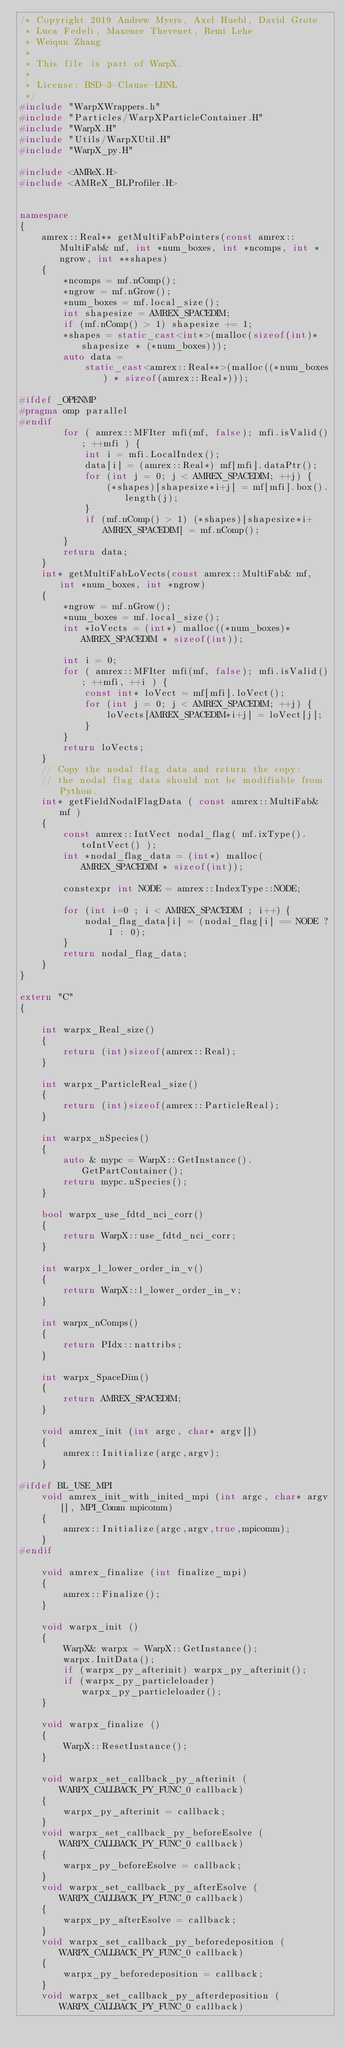Convert code to text. <code><loc_0><loc_0><loc_500><loc_500><_C++_>/* Copyright 2019 Andrew Myers, Axel Huebl, David Grote
 * Luca Fedeli, Maxence Thevenet, Remi Lehe
 * Weiqun Zhang
 *
 * This file is part of WarpX.
 *
 * License: BSD-3-Clause-LBNL
 */
#include "WarpXWrappers.h"
#include "Particles/WarpXParticleContainer.H"
#include "WarpX.H"
#include "Utils/WarpXUtil.H"
#include "WarpX_py.H"

#include <AMReX.H>
#include <AMReX_BLProfiler.H>


namespace
{
    amrex::Real** getMultiFabPointers(const amrex::MultiFab& mf, int *num_boxes, int *ncomps, int *ngrow, int **shapes)
    {
        *ncomps = mf.nComp();
        *ngrow = mf.nGrow();
        *num_boxes = mf.local_size();
        int shapesize = AMREX_SPACEDIM;
        if (mf.nComp() > 1) shapesize += 1;
        *shapes = static_cast<int*>(malloc(sizeof(int)*shapesize * (*num_boxes)));
        auto data =
            static_cast<amrex::Real**>(malloc((*num_boxes) * sizeof(amrex::Real*)));

#ifdef _OPENMP
#pragma omp parallel
#endif
        for ( amrex::MFIter mfi(mf, false); mfi.isValid(); ++mfi ) {
            int i = mfi.LocalIndex();
            data[i] = (amrex::Real*) mf[mfi].dataPtr();
            for (int j = 0; j < AMREX_SPACEDIM; ++j) {
                (*shapes)[shapesize*i+j] = mf[mfi].box().length(j);
            }
            if (mf.nComp() > 1) (*shapes)[shapesize*i+AMREX_SPACEDIM] = mf.nComp();
        }
        return data;
    }
    int* getMultiFabLoVects(const amrex::MultiFab& mf, int *num_boxes, int *ngrow)
    {
        *ngrow = mf.nGrow();
        *num_boxes = mf.local_size();
        int *loVects = (int*) malloc((*num_boxes)*AMREX_SPACEDIM * sizeof(int));

        int i = 0;
        for ( amrex::MFIter mfi(mf, false); mfi.isValid(); ++mfi, ++i ) {
            const int* loVect = mf[mfi].loVect();
            for (int j = 0; j < AMREX_SPACEDIM; ++j) {
                loVects[AMREX_SPACEDIM*i+j] = loVect[j];
            }
        }
        return loVects;
    }
    // Copy the nodal flag data and return the copy:
    // the nodal flag data should not be modifiable from Python.
    int* getFieldNodalFlagData ( const amrex::MultiFab& mf )
    {
        const amrex::IntVect nodal_flag( mf.ixType().toIntVect() );
        int *nodal_flag_data = (int*) malloc(AMREX_SPACEDIM * sizeof(int));

        constexpr int NODE = amrex::IndexType::NODE;

        for (int i=0 ; i < AMREX_SPACEDIM ; i++) {
            nodal_flag_data[i] = (nodal_flag[i] == NODE ? 1 : 0);
        }
        return nodal_flag_data;
    }
}

extern "C"
{

    int warpx_Real_size()
    {
        return (int)sizeof(amrex::Real);
    }

    int warpx_ParticleReal_size()
    {
        return (int)sizeof(amrex::ParticleReal);
    }

    int warpx_nSpecies()
    {
        auto & mypc = WarpX::GetInstance().GetPartContainer();
        return mypc.nSpecies();
    }

    bool warpx_use_fdtd_nci_corr()
    {
        return WarpX::use_fdtd_nci_corr;
    }

    int warpx_l_lower_order_in_v()
    {
        return WarpX::l_lower_order_in_v;
    }

    int warpx_nComps()
    {
        return PIdx::nattribs;
    }

    int warpx_SpaceDim()
    {
        return AMREX_SPACEDIM;
    }

    void amrex_init (int argc, char* argv[])
    {
        amrex::Initialize(argc,argv);
    }

#ifdef BL_USE_MPI
    void amrex_init_with_inited_mpi (int argc, char* argv[], MPI_Comm mpicomm)
    {
        amrex::Initialize(argc,argv,true,mpicomm);
    }
#endif

    void amrex_finalize (int finalize_mpi)
    {
        amrex::Finalize();
    }

    void warpx_init ()
    {
        WarpX& warpx = WarpX::GetInstance();
        warpx.InitData();
        if (warpx_py_afterinit) warpx_py_afterinit();
        if (warpx_py_particleloader) warpx_py_particleloader();
    }

    void warpx_finalize ()
    {
        WarpX::ResetInstance();
    }

    void warpx_set_callback_py_afterinit (WARPX_CALLBACK_PY_FUNC_0 callback)
    {
        warpx_py_afterinit = callback;
    }
    void warpx_set_callback_py_beforeEsolve (WARPX_CALLBACK_PY_FUNC_0 callback)
    {
        warpx_py_beforeEsolve = callback;
    }
    void warpx_set_callback_py_afterEsolve (WARPX_CALLBACK_PY_FUNC_0 callback)
    {
        warpx_py_afterEsolve = callback;
    }
    void warpx_set_callback_py_beforedeposition (WARPX_CALLBACK_PY_FUNC_0 callback)
    {
        warpx_py_beforedeposition = callback;
    }
    void warpx_set_callback_py_afterdeposition (WARPX_CALLBACK_PY_FUNC_0 callback)</code> 